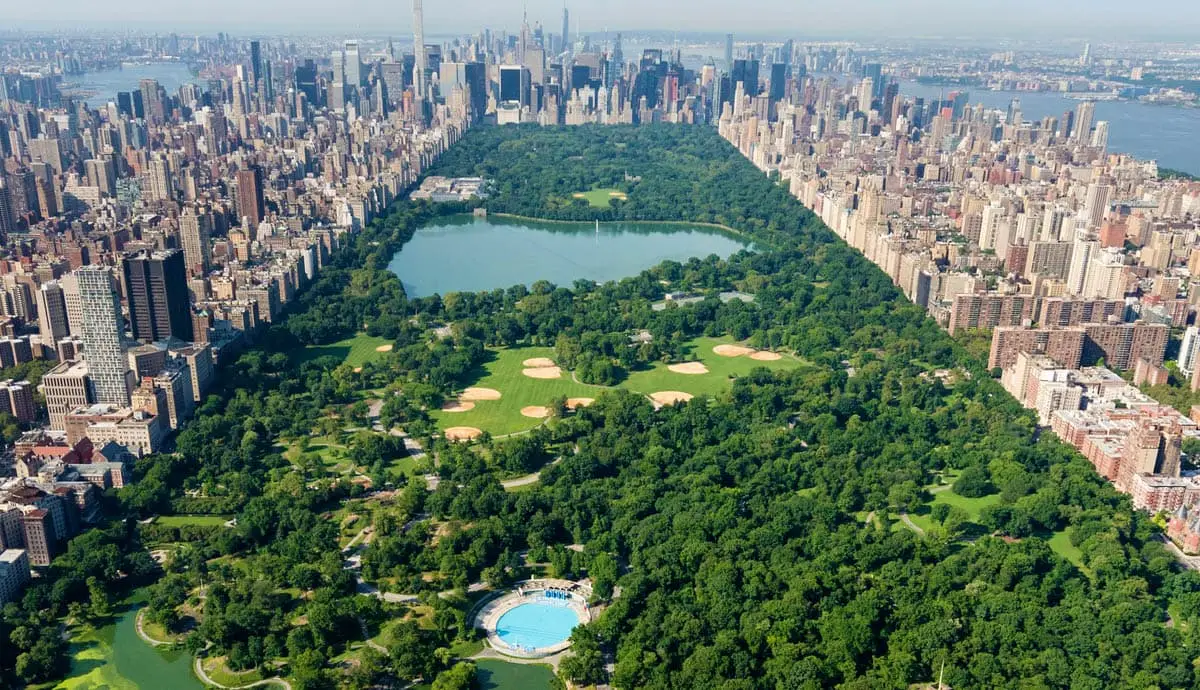What is this photo about? This image offers a stunning aerial view of Central Park in New York City, showcasing its expansive patches of lush greenery set amidst an urban expanse. Central Park serves as a vital green oasis in Manhattan, featuring well-maintained lawns, scattered water bodies such as The Jacqueline Kennedy Onassis Reservoir visible as the large lake, and several recreational areas including baseball fields and tennis courts seen in the image. The surrounding high-rise buildings encapsulate the park, highlighting the park's role as a peaceful haven within the bustling city environment. The contrast between nature and urbanization in this image illustrates Central Park’s importance as a place of refuge and recreation for city dwellers. 